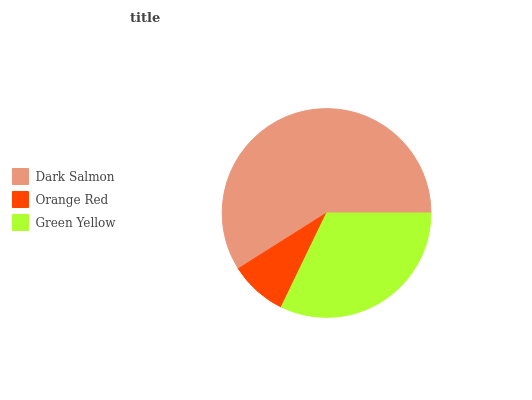Is Orange Red the minimum?
Answer yes or no. Yes. Is Dark Salmon the maximum?
Answer yes or no. Yes. Is Green Yellow the minimum?
Answer yes or no. No. Is Green Yellow the maximum?
Answer yes or no. No. Is Green Yellow greater than Orange Red?
Answer yes or no. Yes. Is Orange Red less than Green Yellow?
Answer yes or no. Yes. Is Orange Red greater than Green Yellow?
Answer yes or no. No. Is Green Yellow less than Orange Red?
Answer yes or no. No. Is Green Yellow the high median?
Answer yes or no. Yes. Is Green Yellow the low median?
Answer yes or no. Yes. Is Dark Salmon the high median?
Answer yes or no. No. Is Orange Red the low median?
Answer yes or no. No. 